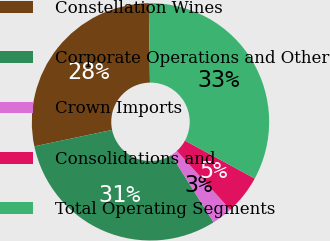Convert chart to OTSL. <chart><loc_0><loc_0><loc_500><loc_500><pie_chart><fcel>Constellation Wines<fcel>Corporate Operations and Other<fcel>Crown Imports<fcel>Consolidations and<fcel>Total Operating Segments<nl><fcel>28.09%<fcel>30.62%<fcel>2.81%<fcel>5.34%<fcel>33.15%<nl></chart> 